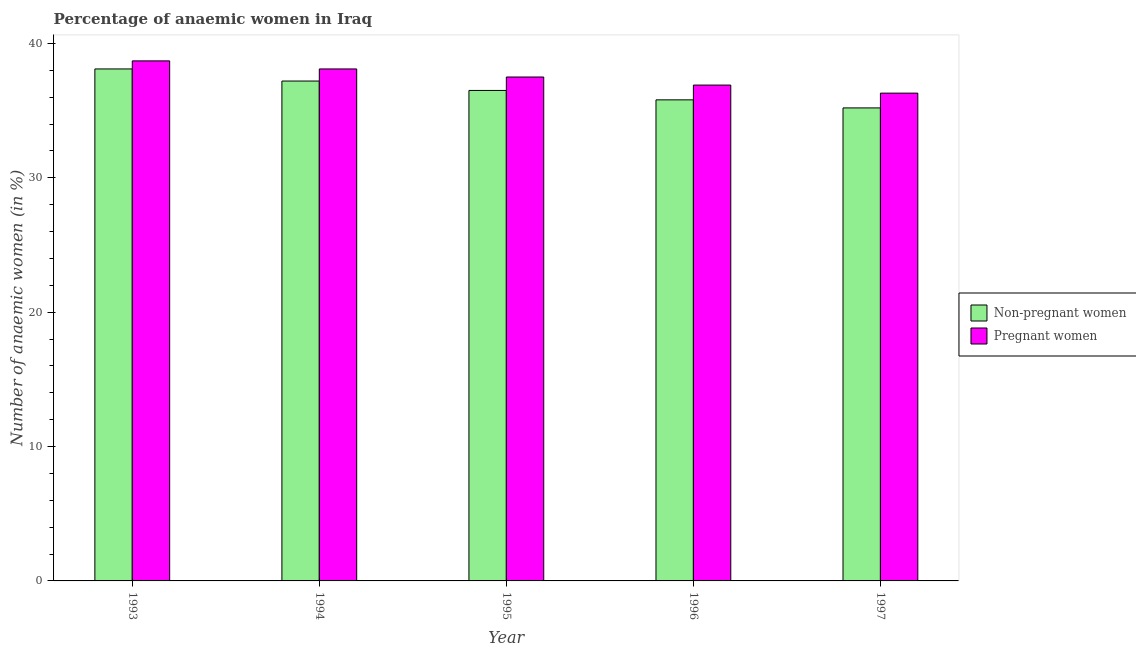How many different coloured bars are there?
Keep it short and to the point. 2. How many groups of bars are there?
Keep it short and to the point. 5. Are the number of bars on each tick of the X-axis equal?
Provide a succinct answer. Yes. How many bars are there on the 2nd tick from the left?
Offer a very short reply. 2. How many bars are there on the 1st tick from the right?
Provide a short and direct response. 2. What is the percentage of non-pregnant anaemic women in 1996?
Provide a succinct answer. 35.8. Across all years, what is the maximum percentage of non-pregnant anaemic women?
Offer a very short reply. 38.1. Across all years, what is the minimum percentage of pregnant anaemic women?
Offer a very short reply. 36.3. What is the total percentage of pregnant anaemic women in the graph?
Offer a very short reply. 187.5. What is the difference between the percentage of non-pregnant anaemic women in 1996 and that in 1997?
Keep it short and to the point. 0.6. What is the difference between the percentage of non-pregnant anaemic women in 1993 and the percentage of pregnant anaemic women in 1995?
Your response must be concise. 1.6. What is the average percentage of pregnant anaemic women per year?
Make the answer very short. 37.5. In the year 1997, what is the difference between the percentage of pregnant anaemic women and percentage of non-pregnant anaemic women?
Make the answer very short. 0. In how many years, is the percentage of pregnant anaemic women greater than 18 %?
Your answer should be compact. 5. What is the ratio of the percentage of pregnant anaemic women in 1996 to that in 1997?
Your response must be concise. 1.02. Is the difference between the percentage of pregnant anaemic women in 1993 and 1995 greater than the difference between the percentage of non-pregnant anaemic women in 1993 and 1995?
Provide a short and direct response. No. What is the difference between the highest and the second highest percentage of pregnant anaemic women?
Your response must be concise. 0.6. What is the difference between the highest and the lowest percentage of pregnant anaemic women?
Offer a terse response. 2.4. In how many years, is the percentage of non-pregnant anaemic women greater than the average percentage of non-pregnant anaemic women taken over all years?
Provide a succinct answer. 2. Is the sum of the percentage of non-pregnant anaemic women in 1996 and 1997 greater than the maximum percentage of pregnant anaemic women across all years?
Give a very brief answer. Yes. What does the 1st bar from the left in 1997 represents?
Provide a succinct answer. Non-pregnant women. What does the 1st bar from the right in 1996 represents?
Your response must be concise. Pregnant women. Are the values on the major ticks of Y-axis written in scientific E-notation?
Offer a very short reply. No. How are the legend labels stacked?
Offer a very short reply. Vertical. What is the title of the graph?
Give a very brief answer. Percentage of anaemic women in Iraq. What is the label or title of the X-axis?
Your response must be concise. Year. What is the label or title of the Y-axis?
Offer a very short reply. Number of anaemic women (in %). What is the Number of anaemic women (in %) of Non-pregnant women in 1993?
Your response must be concise. 38.1. What is the Number of anaemic women (in %) of Pregnant women in 1993?
Provide a succinct answer. 38.7. What is the Number of anaemic women (in %) in Non-pregnant women in 1994?
Your answer should be very brief. 37.2. What is the Number of anaemic women (in %) of Pregnant women in 1994?
Offer a very short reply. 38.1. What is the Number of anaemic women (in %) in Non-pregnant women in 1995?
Your answer should be very brief. 36.5. What is the Number of anaemic women (in %) of Pregnant women in 1995?
Your response must be concise. 37.5. What is the Number of anaemic women (in %) of Non-pregnant women in 1996?
Ensure brevity in your answer.  35.8. What is the Number of anaemic women (in %) of Pregnant women in 1996?
Give a very brief answer. 36.9. What is the Number of anaemic women (in %) of Non-pregnant women in 1997?
Offer a very short reply. 35.2. What is the Number of anaemic women (in %) in Pregnant women in 1997?
Your response must be concise. 36.3. Across all years, what is the maximum Number of anaemic women (in %) of Non-pregnant women?
Provide a succinct answer. 38.1. Across all years, what is the maximum Number of anaemic women (in %) of Pregnant women?
Your response must be concise. 38.7. Across all years, what is the minimum Number of anaemic women (in %) in Non-pregnant women?
Keep it short and to the point. 35.2. Across all years, what is the minimum Number of anaemic women (in %) in Pregnant women?
Offer a very short reply. 36.3. What is the total Number of anaemic women (in %) in Non-pregnant women in the graph?
Give a very brief answer. 182.8. What is the total Number of anaemic women (in %) in Pregnant women in the graph?
Offer a terse response. 187.5. What is the difference between the Number of anaemic women (in %) of Non-pregnant women in 1993 and that in 1994?
Offer a terse response. 0.9. What is the difference between the Number of anaemic women (in %) of Pregnant women in 1993 and that in 1994?
Keep it short and to the point. 0.6. What is the difference between the Number of anaemic women (in %) in Pregnant women in 1993 and that in 1996?
Provide a succinct answer. 1.8. What is the difference between the Number of anaemic women (in %) of Non-pregnant women in 1994 and that in 1996?
Your answer should be compact. 1.4. What is the difference between the Number of anaemic women (in %) in Non-pregnant women in 1994 and that in 1997?
Provide a short and direct response. 2. What is the difference between the Number of anaemic women (in %) in Pregnant women in 1994 and that in 1997?
Your answer should be very brief. 1.8. What is the difference between the Number of anaemic women (in %) of Non-pregnant women in 1995 and that in 1996?
Give a very brief answer. 0.7. What is the difference between the Number of anaemic women (in %) of Pregnant women in 1995 and that in 1996?
Your answer should be compact. 0.6. What is the difference between the Number of anaemic women (in %) of Non-pregnant women in 1995 and that in 1997?
Offer a terse response. 1.3. What is the difference between the Number of anaemic women (in %) in Pregnant women in 1995 and that in 1997?
Offer a very short reply. 1.2. What is the difference between the Number of anaemic women (in %) of Non-pregnant women in 1993 and the Number of anaemic women (in %) of Pregnant women in 1994?
Offer a very short reply. 0. What is the difference between the Number of anaemic women (in %) of Non-pregnant women in 1993 and the Number of anaemic women (in %) of Pregnant women in 1995?
Your answer should be very brief. 0.6. What is the difference between the Number of anaemic women (in %) of Non-pregnant women in 1993 and the Number of anaemic women (in %) of Pregnant women in 1997?
Offer a very short reply. 1.8. What is the difference between the Number of anaemic women (in %) in Non-pregnant women in 1994 and the Number of anaemic women (in %) in Pregnant women in 1997?
Keep it short and to the point. 0.9. What is the difference between the Number of anaemic women (in %) of Non-pregnant women in 1996 and the Number of anaemic women (in %) of Pregnant women in 1997?
Your answer should be very brief. -0.5. What is the average Number of anaemic women (in %) in Non-pregnant women per year?
Give a very brief answer. 36.56. What is the average Number of anaemic women (in %) in Pregnant women per year?
Keep it short and to the point. 37.5. In the year 1993, what is the difference between the Number of anaemic women (in %) of Non-pregnant women and Number of anaemic women (in %) of Pregnant women?
Ensure brevity in your answer.  -0.6. In the year 1994, what is the difference between the Number of anaemic women (in %) in Non-pregnant women and Number of anaemic women (in %) in Pregnant women?
Offer a very short reply. -0.9. In the year 1996, what is the difference between the Number of anaemic women (in %) in Non-pregnant women and Number of anaemic women (in %) in Pregnant women?
Provide a succinct answer. -1.1. What is the ratio of the Number of anaemic women (in %) of Non-pregnant women in 1993 to that in 1994?
Keep it short and to the point. 1.02. What is the ratio of the Number of anaemic women (in %) in Pregnant women in 1993 to that in 1994?
Ensure brevity in your answer.  1.02. What is the ratio of the Number of anaemic women (in %) of Non-pregnant women in 1993 to that in 1995?
Provide a short and direct response. 1.04. What is the ratio of the Number of anaemic women (in %) of Pregnant women in 1993 to that in 1995?
Offer a terse response. 1.03. What is the ratio of the Number of anaemic women (in %) in Non-pregnant women in 1993 to that in 1996?
Your answer should be compact. 1.06. What is the ratio of the Number of anaemic women (in %) in Pregnant women in 1993 to that in 1996?
Your answer should be compact. 1.05. What is the ratio of the Number of anaemic women (in %) in Non-pregnant women in 1993 to that in 1997?
Keep it short and to the point. 1.08. What is the ratio of the Number of anaemic women (in %) in Pregnant women in 1993 to that in 1997?
Your response must be concise. 1.07. What is the ratio of the Number of anaemic women (in %) of Non-pregnant women in 1994 to that in 1995?
Your response must be concise. 1.02. What is the ratio of the Number of anaemic women (in %) in Pregnant women in 1994 to that in 1995?
Make the answer very short. 1.02. What is the ratio of the Number of anaemic women (in %) of Non-pregnant women in 1994 to that in 1996?
Offer a very short reply. 1.04. What is the ratio of the Number of anaemic women (in %) of Pregnant women in 1994 to that in 1996?
Your answer should be very brief. 1.03. What is the ratio of the Number of anaemic women (in %) in Non-pregnant women in 1994 to that in 1997?
Your response must be concise. 1.06. What is the ratio of the Number of anaemic women (in %) of Pregnant women in 1994 to that in 1997?
Give a very brief answer. 1.05. What is the ratio of the Number of anaemic women (in %) of Non-pregnant women in 1995 to that in 1996?
Provide a succinct answer. 1.02. What is the ratio of the Number of anaemic women (in %) of Pregnant women in 1995 to that in 1996?
Keep it short and to the point. 1.02. What is the ratio of the Number of anaemic women (in %) in Non-pregnant women in 1995 to that in 1997?
Offer a terse response. 1.04. What is the ratio of the Number of anaemic women (in %) in Pregnant women in 1995 to that in 1997?
Ensure brevity in your answer.  1.03. What is the ratio of the Number of anaemic women (in %) of Non-pregnant women in 1996 to that in 1997?
Offer a terse response. 1.02. What is the ratio of the Number of anaemic women (in %) in Pregnant women in 1996 to that in 1997?
Provide a short and direct response. 1.02. What is the difference between the highest and the lowest Number of anaemic women (in %) in Pregnant women?
Make the answer very short. 2.4. 